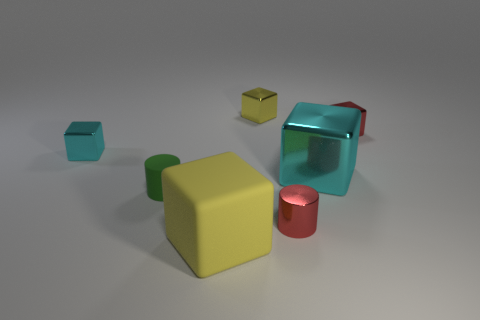What is the color of the big rubber thing that is the same shape as the tiny yellow thing?
Make the answer very short. Yellow. What color is the object that is made of the same material as the green cylinder?
Your answer should be compact. Yellow. How many yellow blocks are the same size as the red cube?
Provide a short and direct response. 1. What is the small cyan thing made of?
Your answer should be compact. Metal. Is the number of small things greater than the number of large cyan rubber cubes?
Provide a short and direct response. Yes. Is the green thing the same shape as the tiny cyan object?
Make the answer very short. No. Is there anything else that is the same shape as the large yellow rubber object?
Your response must be concise. Yes. Is the color of the shiny object that is behind the tiny red block the same as the large thing that is in front of the tiny red cylinder?
Give a very brief answer. Yes. Are there fewer small yellow objects behind the yellow metallic block than cyan things that are in front of the yellow rubber block?
Offer a terse response. No. What shape is the yellow thing that is to the left of the yellow metal object?
Your answer should be compact. Cube. 